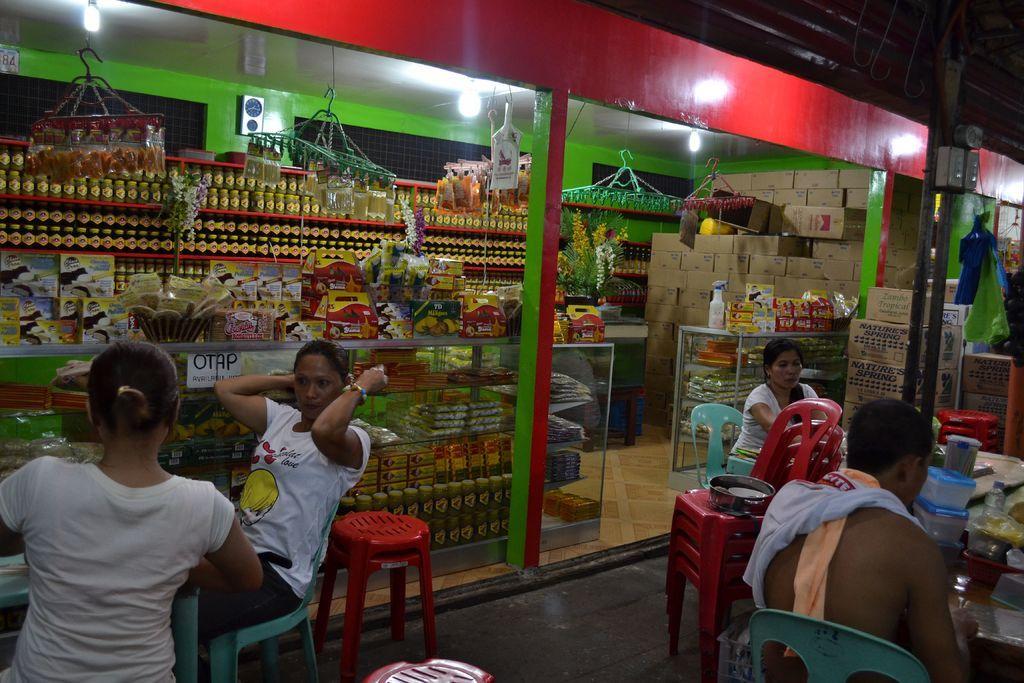In one or two sentences, can you explain what this image depicts? Four people are sitting in chairs in front of a store. 